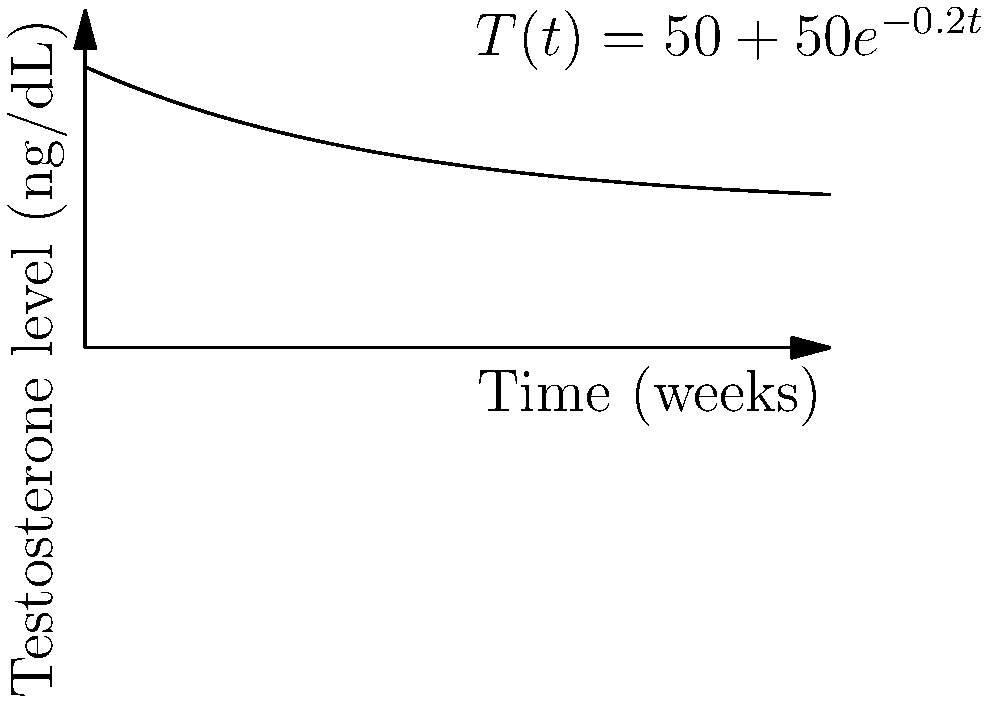The graph represents the testosterone levels in a transgender man undergoing hormone replacement therapy. The function $T(t) = 50 + 50e^{-0.2t}$ models the testosterone level (in ng/dL) at time $t$ (in weeks). At what rate is the testosterone level changing after 5 weeks of treatment? To find the rate of change in testosterone levels after 5 weeks, we need to calculate the derivative of the function $T(t)$ and evaluate it at $t=5$. Here's the step-by-step process:

1) The given function is $T(t) = 50 + 50e^{-0.2t}$

2) To find the derivative, we use the chain rule:
   $$\frac{dT}{dt} = 0 + 50 \cdot (-0.2) \cdot e^{-0.2t} = -10e^{-0.2t}$$

3) Now we evaluate this derivative at $t=5$:
   $$\frac{dT}{dt}\bigg|_{t=5} = -10e^{-0.2(5)} = -10e^{-1} \approx -3.68$$

4) The negative value indicates that the testosterone level is decreasing.

5) The units of the rate of change will be ng/dL per week.
Answer: $-3.68$ ng/dL per week 